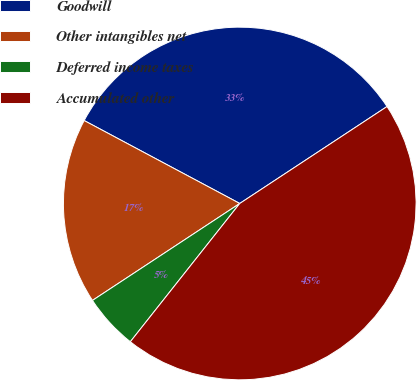Convert chart to OTSL. <chart><loc_0><loc_0><loc_500><loc_500><pie_chart><fcel>Goodwill<fcel>Other intangibles net<fcel>Deferred income taxes<fcel>Accumulated other<nl><fcel>32.94%<fcel>17.06%<fcel>5.08%<fcel>44.92%<nl></chart> 